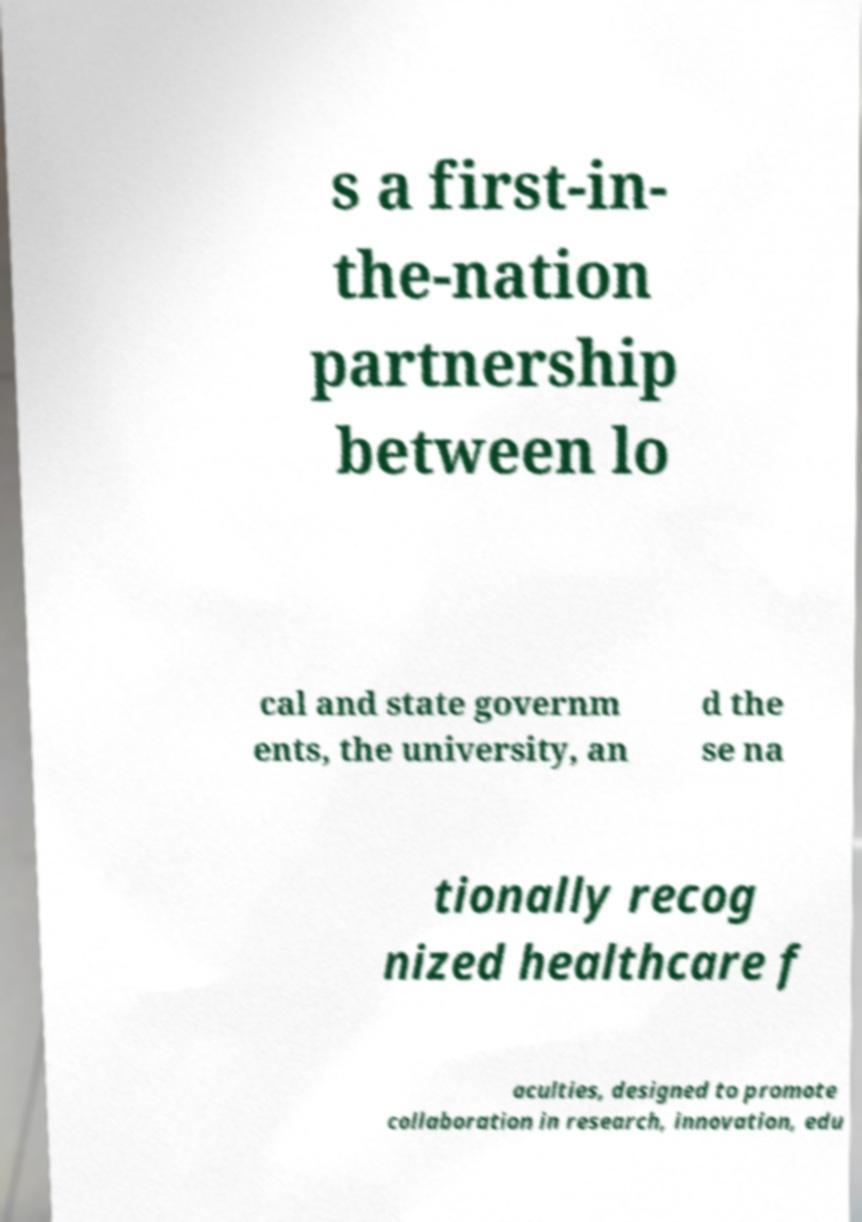Could you extract and type out the text from this image? s a first-in- the-nation partnership between lo cal and state governm ents, the university, an d the se na tionally recog nized healthcare f aculties, designed to promote collaboration in research, innovation, edu 